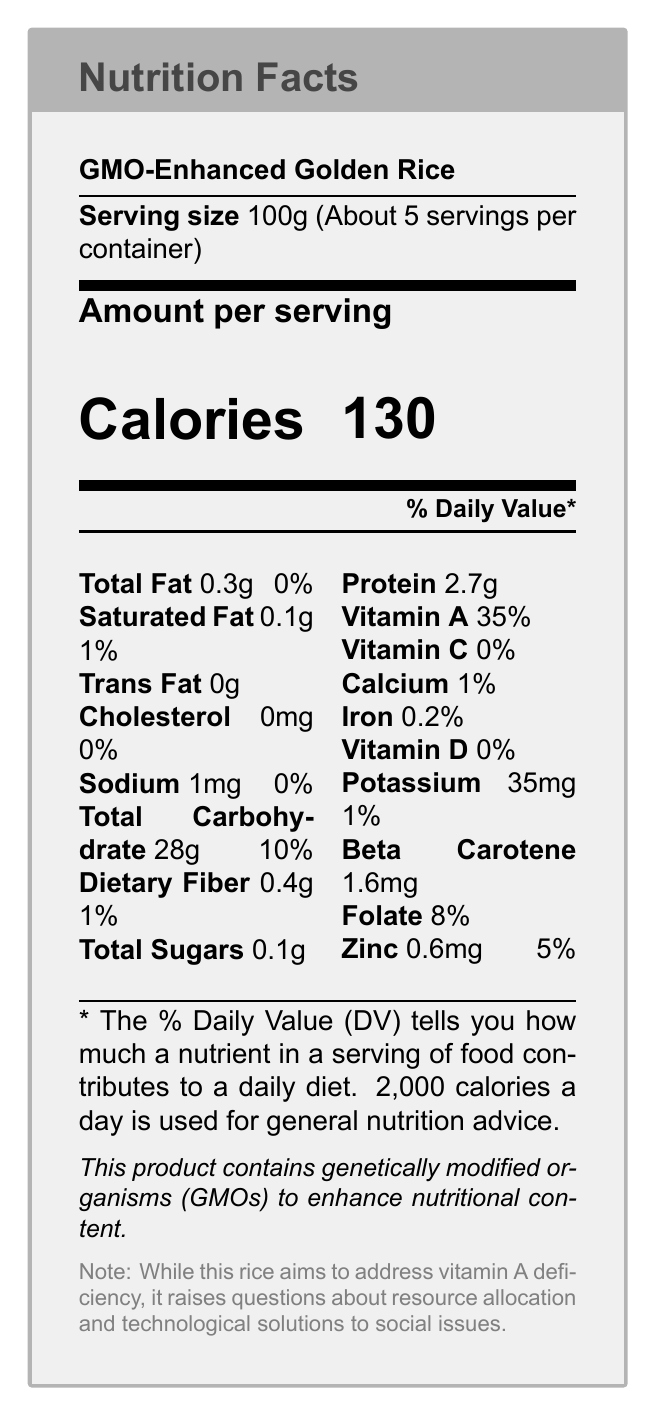what is the serving size of the GMO-Enhanced Golden Rice? The document states that the serving size is 100g.
Answer: 100g how many servings per container does the GMO-Enhanced Golden Rice have? The document indicates that there are about 5 servings per container.
Answer: 5 what is the calorie content per serving? The document shows that each serving of GMO-Enhanced Golden Rice contains 130 calories.
Answer: 130 what percentage of the daily value of Vitamin A is provided per serving? According to the document, one serving provides 35% of the daily value of Vitamin A.
Answer: 35% what are the total carbohydrates in one serving? The document lists the total carbohydrate content per serving as 28g.
Answer: 28g how much dietary fiber does one serving of GMO-Enhanced Golden Rice contain? The document indicates that one serving has 0.4g of dietary fiber.
Answer: 0.4g Does GMO-Enhanced Golden Rice contain any cholesterol? The document states that the cholesterol content is 0mg.
Answer: No What is the total fat content in a single serving? According to the document, the total fat content per serving is 0.3g.
Answer: 0.3g which of the following nutrients does the GMO-Enhanced Golden Rice provide no daily value for? A. Vitamin A B. Vitamin D C. Iron D. Potassium The document shows that Vitamin D has a 0% daily value per serving.
Answer: B what micronutrient in GMO-Enhanced Golden Rice aims to combat vitamin A deficiency? A. Beta Carotene B. Vitamin C C. Folate D. Zinc The document mentions that the product aims to address vitamin A deficiency, which Beta Carotene helps to combat.
Answer: A Does the document mention any societal impact of GMO-Enhanced Golden Rice? The document includes a note discussing resource allocation and technological solutions to social issues related to GMO-Enhanced Golden Rice.
Answer: Yes Summarize the main idea of the document. The document outlines the nutritional details of GMO-Enhanced Golden Rice, emphasizing its role in addressing vitamin A deficiency, and touches on broader issues such as resource allocation, technological solutions to social problems, and potential economic and environmental impacts.
Answer: The document provides the nutritional profile of GMO-Enhanced Golden Rice, highlighting its enhanced Vitamin A content and the associated societal impacts and food justice concerns. How much protein is in one serving of GMO-Enhanced Golden Rice? The document lists the protein content per serving as 2.7g.
Answer: 2.7g What is the additional % Daily Value of Calcium provided if one consumes two servings of GMO-Enhanced Golden Rice? Since one serving provides 1% of the Daily Value of Calcium, two servings would provide 2%.
Answer: 2% Are there any alternative solutions mentioned in the document for addressing malnutrition besides GMO-Enhanced Golden Rice? The detailed section containing additional societal notes is not fully displayed in the graphical part, so this information isn't directly visible in the nutrition facts section itself.
Answer: Cannot be determined from the main graphical part of the document. 